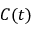Convert formula to latex. <formula><loc_0><loc_0><loc_500><loc_500>C ( t )</formula> 